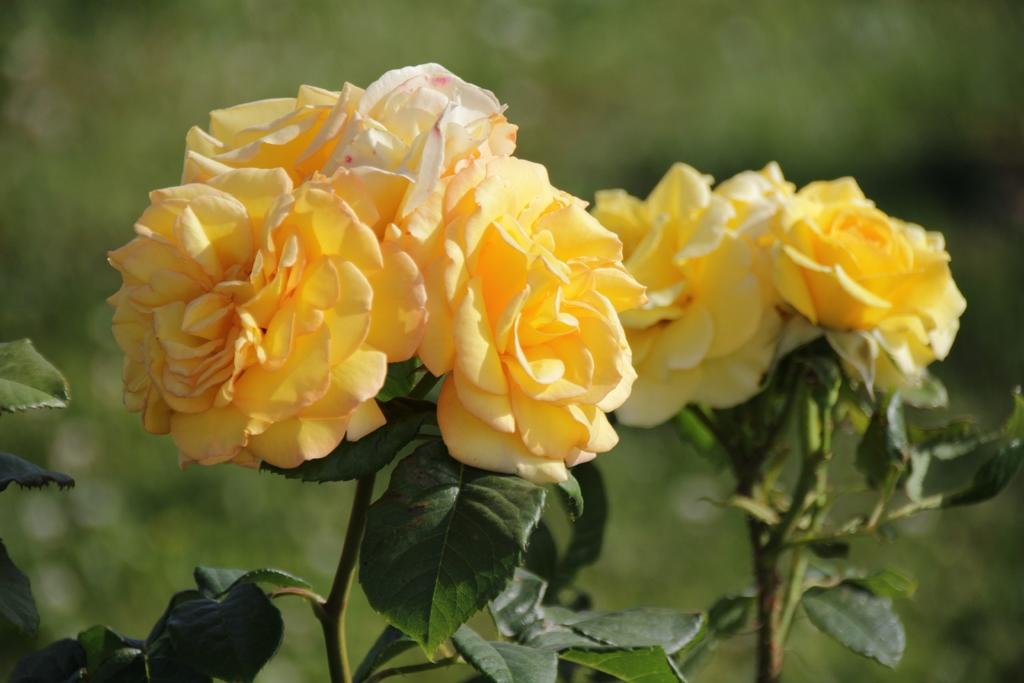What type of plants are in the image? There are rose plants in the image. What color are the rose flowers? The rose flowers are yellow in color. What color is the background of the image? The background of the image is green. How is the image blurred? The image is blurred in the background. What type of locket can be seen hanging from the edge of the image? There is no locket present in the image. What is the answer to the question that is not visible in the image? The question you are referring to is not visible in the image, so it is impossible to provide an answer. 